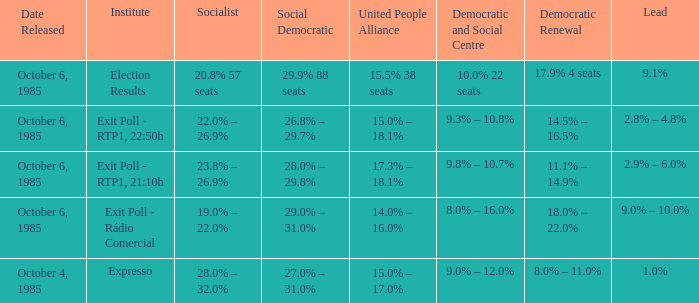0% – 2 Exit Poll - Rádio Comercial. 